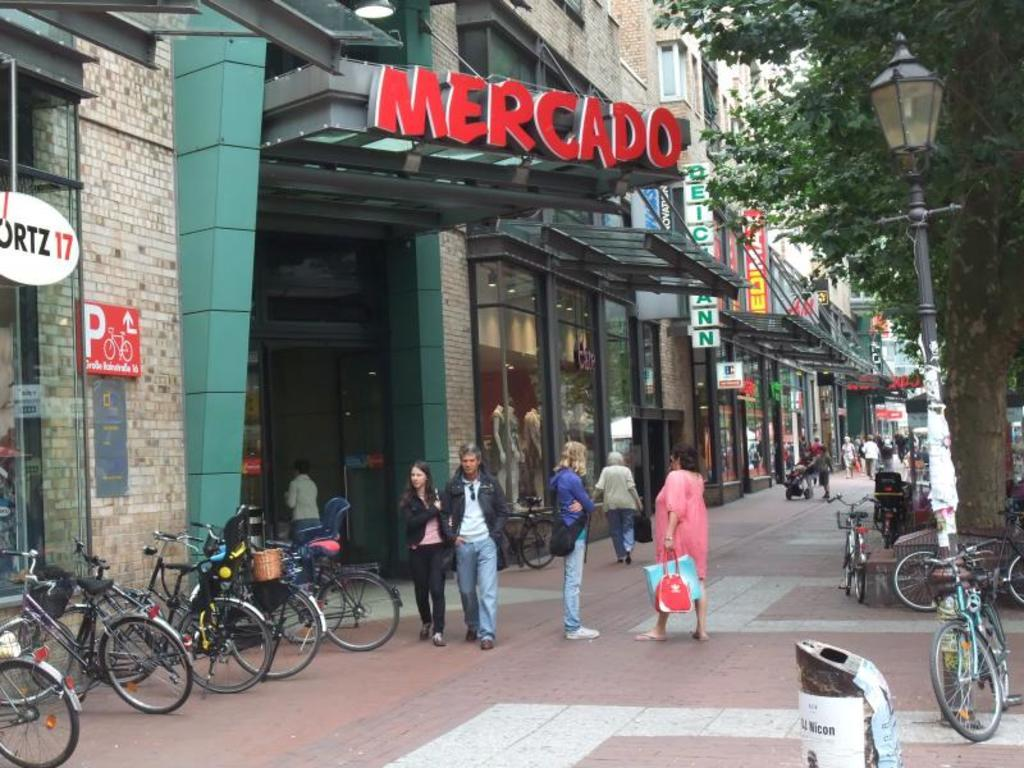How many people are in the group visible in the image? There is a group of people standing in the image, but the exact number cannot be determined from the provided facts. What objects are present in the image for waste disposal? Dustbins are present in the image for waste disposal. What type of vehicles are parked on the path in the image? Bicycles are parked on the path in the image. What type of illumination is visible in the image? There is a light in the image for illumination. What is the purpose of the pole visible in the image? A pole is visible in the image, but its purpose cannot be determined from the provided facts. What type of vegetation is present in the image? Trees are present in the image. What type of structures are visible in the image? Buildings are visible in the image. What objects are present in the image for identification purposes? Name boards are present in the image for identification purposes. Is the queen present in the image? There is no mention of a queen or any royal figure in the provided facts, so it cannot be determined if the queen is present in the image. How hot is the temperature in the image? The provided facts do not mention the temperature or any weather conditions, so it cannot be determined how hot it is in the image. 